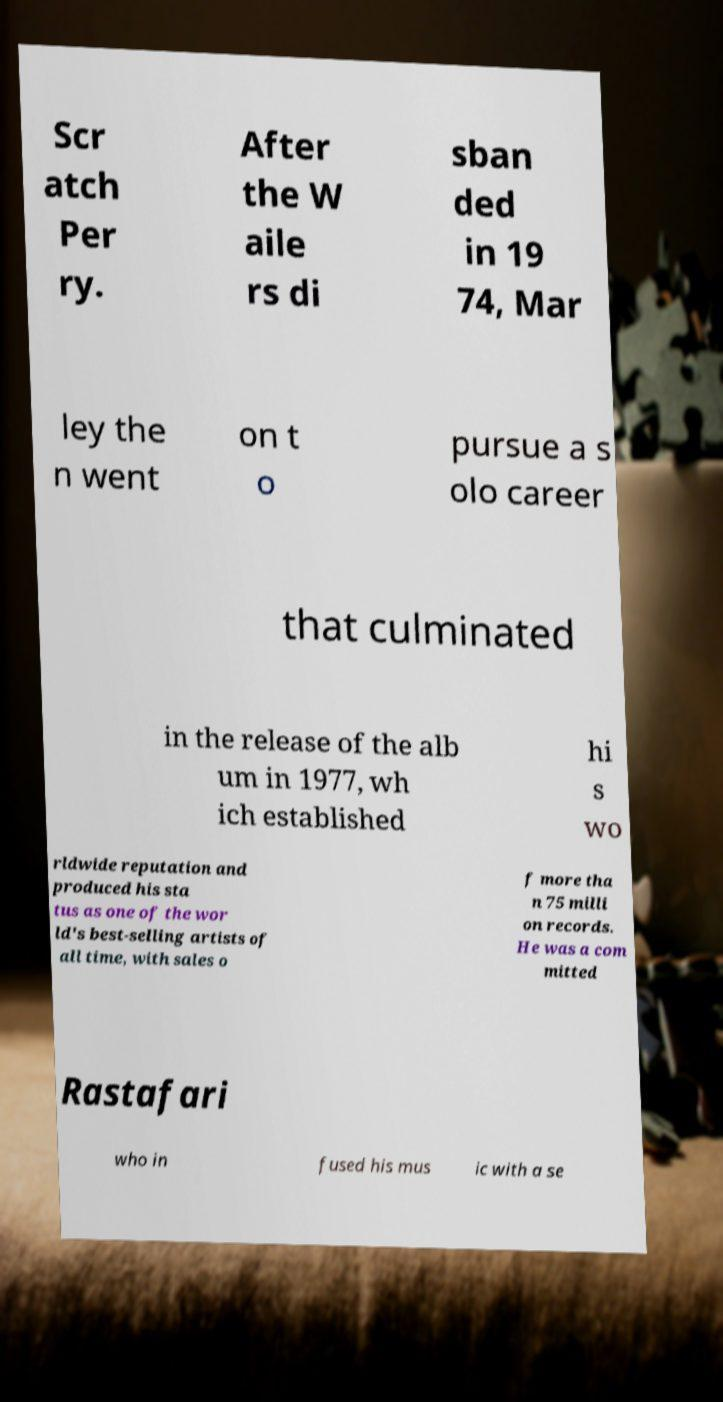I need the written content from this picture converted into text. Can you do that? Scr atch Per ry. After the W aile rs di sban ded in 19 74, Mar ley the n went on t o pursue a s olo career that culminated in the release of the alb um in 1977, wh ich established hi s wo rldwide reputation and produced his sta tus as one of the wor ld's best-selling artists of all time, with sales o f more tha n 75 milli on records. He was a com mitted Rastafari who in fused his mus ic with a se 